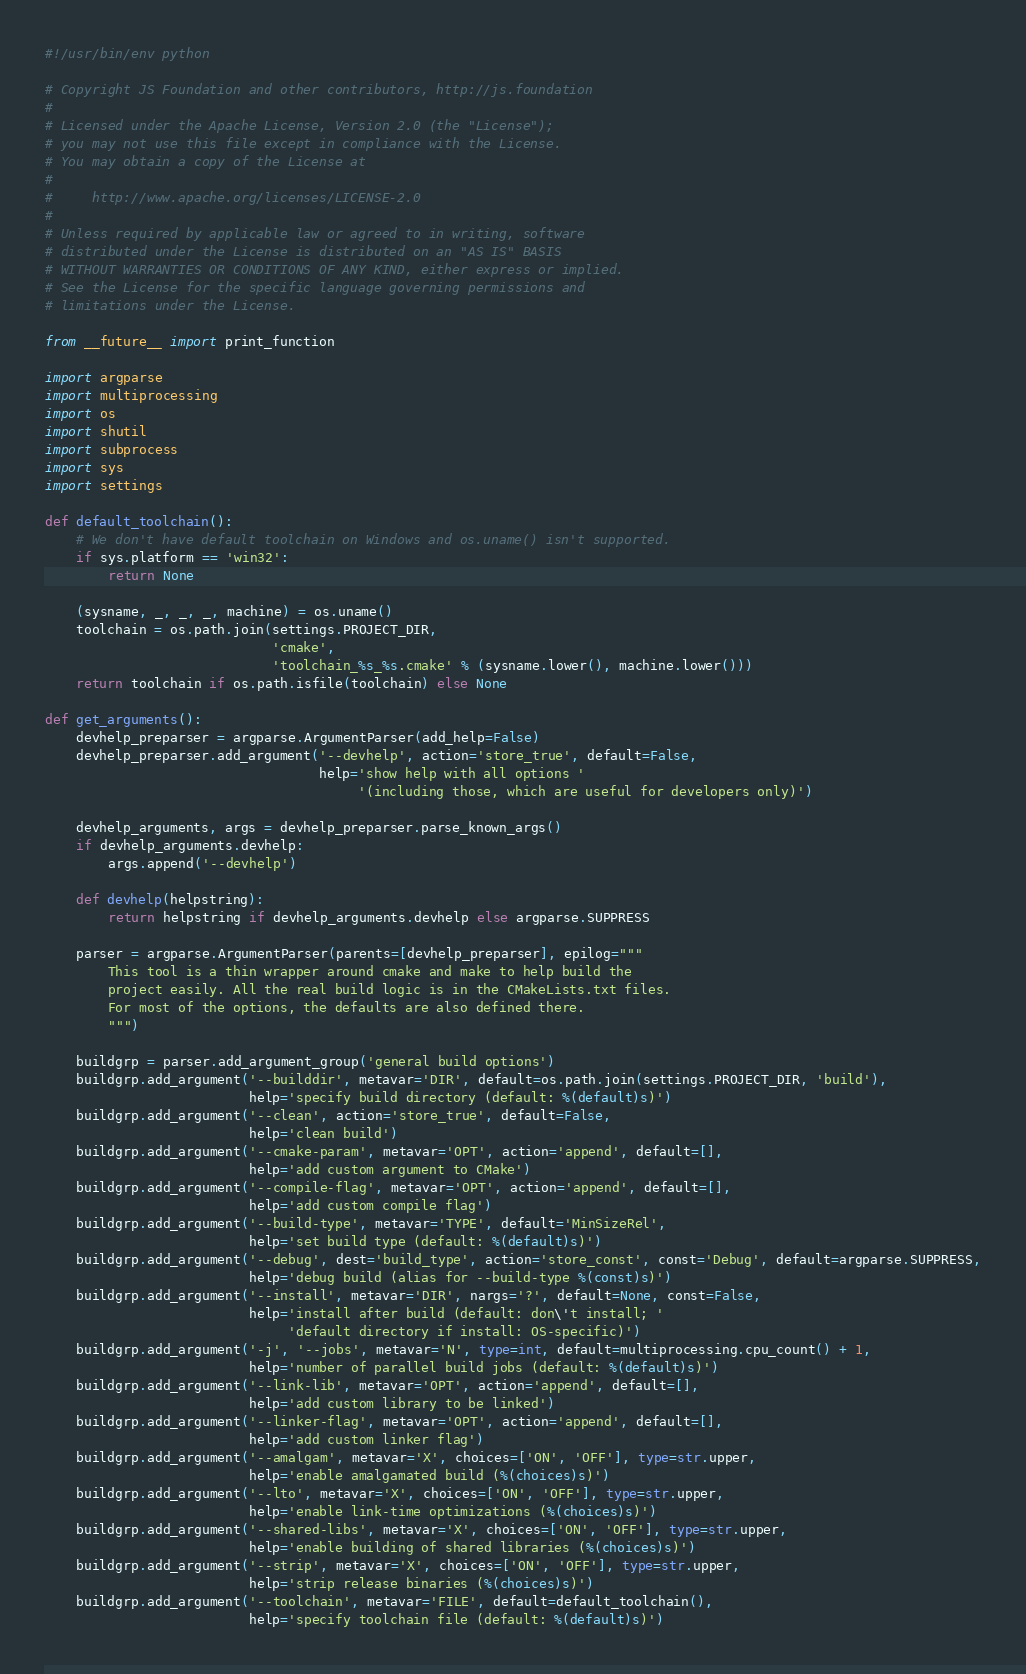<code> <loc_0><loc_0><loc_500><loc_500><_Python_>#!/usr/bin/env python

# Copyright JS Foundation and other contributors, http://js.foundation
#
# Licensed under the Apache License, Version 2.0 (the "License");
# you may not use this file except in compliance with the License.
# You may obtain a copy of the License at
#
#     http://www.apache.org/licenses/LICENSE-2.0
#
# Unless required by applicable law or agreed to in writing, software
# distributed under the License is distributed on an "AS IS" BASIS
# WITHOUT WARRANTIES OR CONDITIONS OF ANY KIND, either express or implied.
# See the License for the specific language governing permissions and
# limitations under the License.

from __future__ import print_function

import argparse
import multiprocessing
import os
import shutil
import subprocess
import sys
import settings

def default_toolchain():
    # We don't have default toolchain on Windows and os.uname() isn't supported.
    if sys.platform == 'win32':
        return None

    (sysname, _, _, _, machine) = os.uname()
    toolchain = os.path.join(settings.PROJECT_DIR,
                             'cmake',
                             'toolchain_%s_%s.cmake' % (sysname.lower(), machine.lower()))
    return toolchain if os.path.isfile(toolchain) else None

def get_arguments():
    devhelp_preparser = argparse.ArgumentParser(add_help=False)
    devhelp_preparser.add_argument('--devhelp', action='store_true', default=False,
                                   help='show help with all options '
                                        '(including those, which are useful for developers only)')

    devhelp_arguments, args = devhelp_preparser.parse_known_args()
    if devhelp_arguments.devhelp:
        args.append('--devhelp')

    def devhelp(helpstring):
        return helpstring if devhelp_arguments.devhelp else argparse.SUPPRESS

    parser = argparse.ArgumentParser(parents=[devhelp_preparser], epilog="""
        This tool is a thin wrapper around cmake and make to help build the
        project easily. All the real build logic is in the CMakeLists.txt files.
        For most of the options, the defaults are also defined there.
        """)

    buildgrp = parser.add_argument_group('general build options')
    buildgrp.add_argument('--builddir', metavar='DIR', default=os.path.join(settings.PROJECT_DIR, 'build'),
                          help='specify build directory (default: %(default)s)')
    buildgrp.add_argument('--clean', action='store_true', default=False,
                          help='clean build')
    buildgrp.add_argument('--cmake-param', metavar='OPT', action='append', default=[],
                          help='add custom argument to CMake')
    buildgrp.add_argument('--compile-flag', metavar='OPT', action='append', default=[],
                          help='add custom compile flag')
    buildgrp.add_argument('--build-type', metavar='TYPE', default='MinSizeRel',
                          help='set build type (default: %(default)s)')
    buildgrp.add_argument('--debug', dest='build_type', action='store_const', const='Debug', default=argparse.SUPPRESS,
                          help='debug build (alias for --build-type %(const)s)')
    buildgrp.add_argument('--install', metavar='DIR', nargs='?', default=None, const=False,
                          help='install after build (default: don\'t install; '
                               'default directory if install: OS-specific)')
    buildgrp.add_argument('-j', '--jobs', metavar='N', type=int, default=multiprocessing.cpu_count() + 1,
                          help='number of parallel build jobs (default: %(default)s)')
    buildgrp.add_argument('--link-lib', metavar='OPT', action='append', default=[],
                          help='add custom library to be linked')
    buildgrp.add_argument('--linker-flag', metavar='OPT', action='append', default=[],
                          help='add custom linker flag')
    buildgrp.add_argument('--amalgam', metavar='X', choices=['ON', 'OFF'], type=str.upper,
                          help='enable amalgamated build (%(choices)s)')
    buildgrp.add_argument('--lto', metavar='X', choices=['ON', 'OFF'], type=str.upper,
                          help='enable link-time optimizations (%(choices)s)')
    buildgrp.add_argument('--shared-libs', metavar='X', choices=['ON', 'OFF'], type=str.upper,
                          help='enable building of shared libraries (%(choices)s)')
    buildgrp.add_argument('--strip', metavar='X', choices=['ON', 'OFF'], type=str.upper,
                          help='strip release binaries (%(choices)s)')
    buildgrp.add_argument('--toolchain', metavar='FILE', default=default_toolchain(),
                          help='specify toolchain file (default: %(default)s)')</code> 